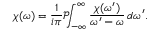Convert formula to latex. <formula><loc_0><loc_0><loc_500><loc_500>\chi ( \omega ) = { \frac { 1 } { i \pi } } { \mathcal { P } } \, \int _ { - \infty } ^ { \infty } { \frac { \chi ( \omega ^ { \prime } ) } { \omega ^ { \prime } - \omega } } \, d \omega ^ { \prime } .</formula> 